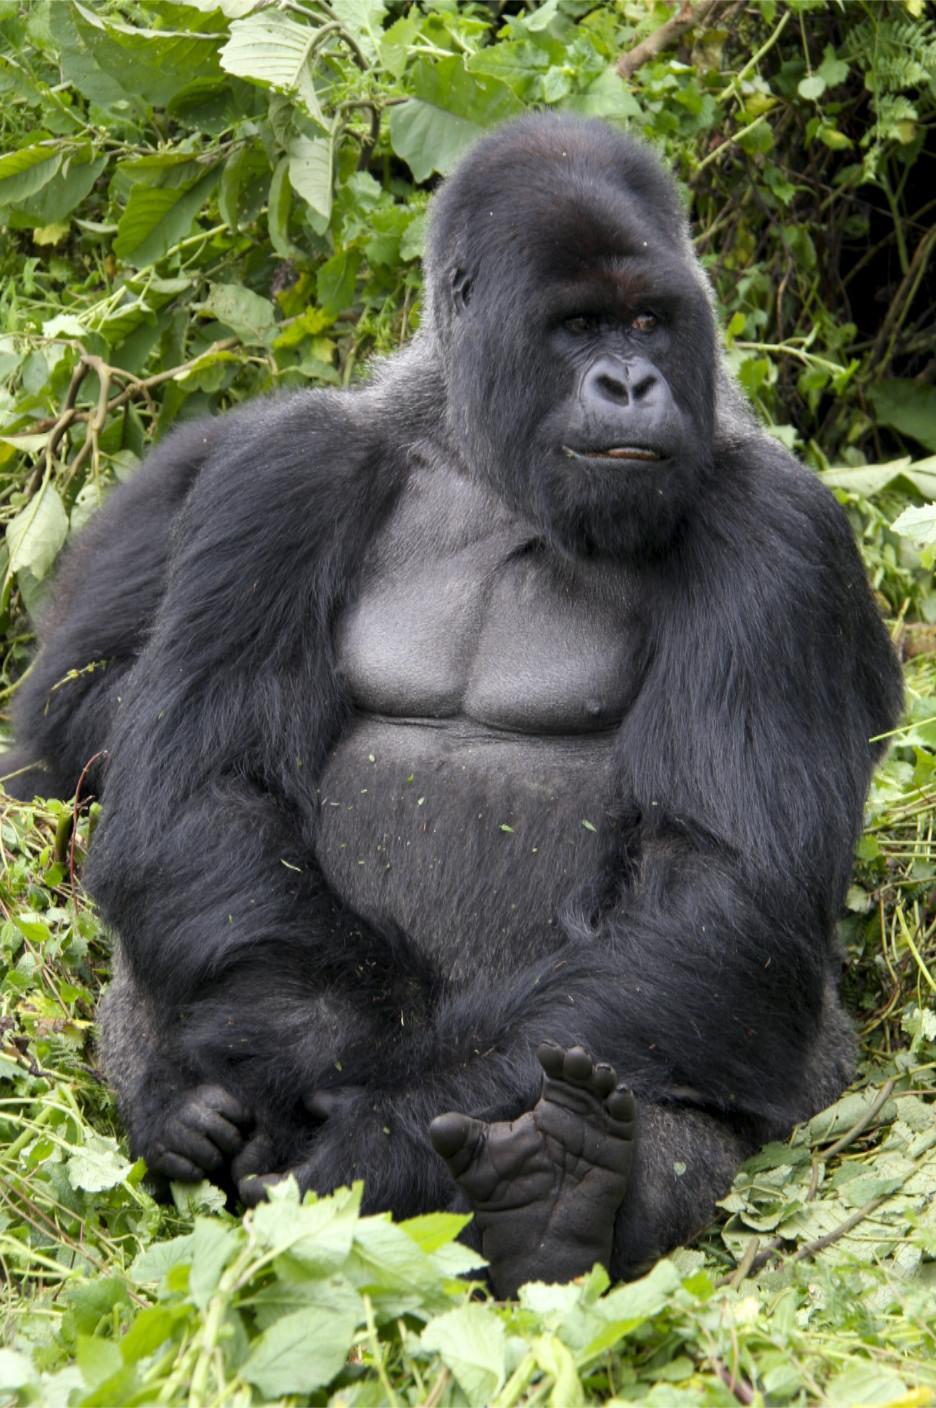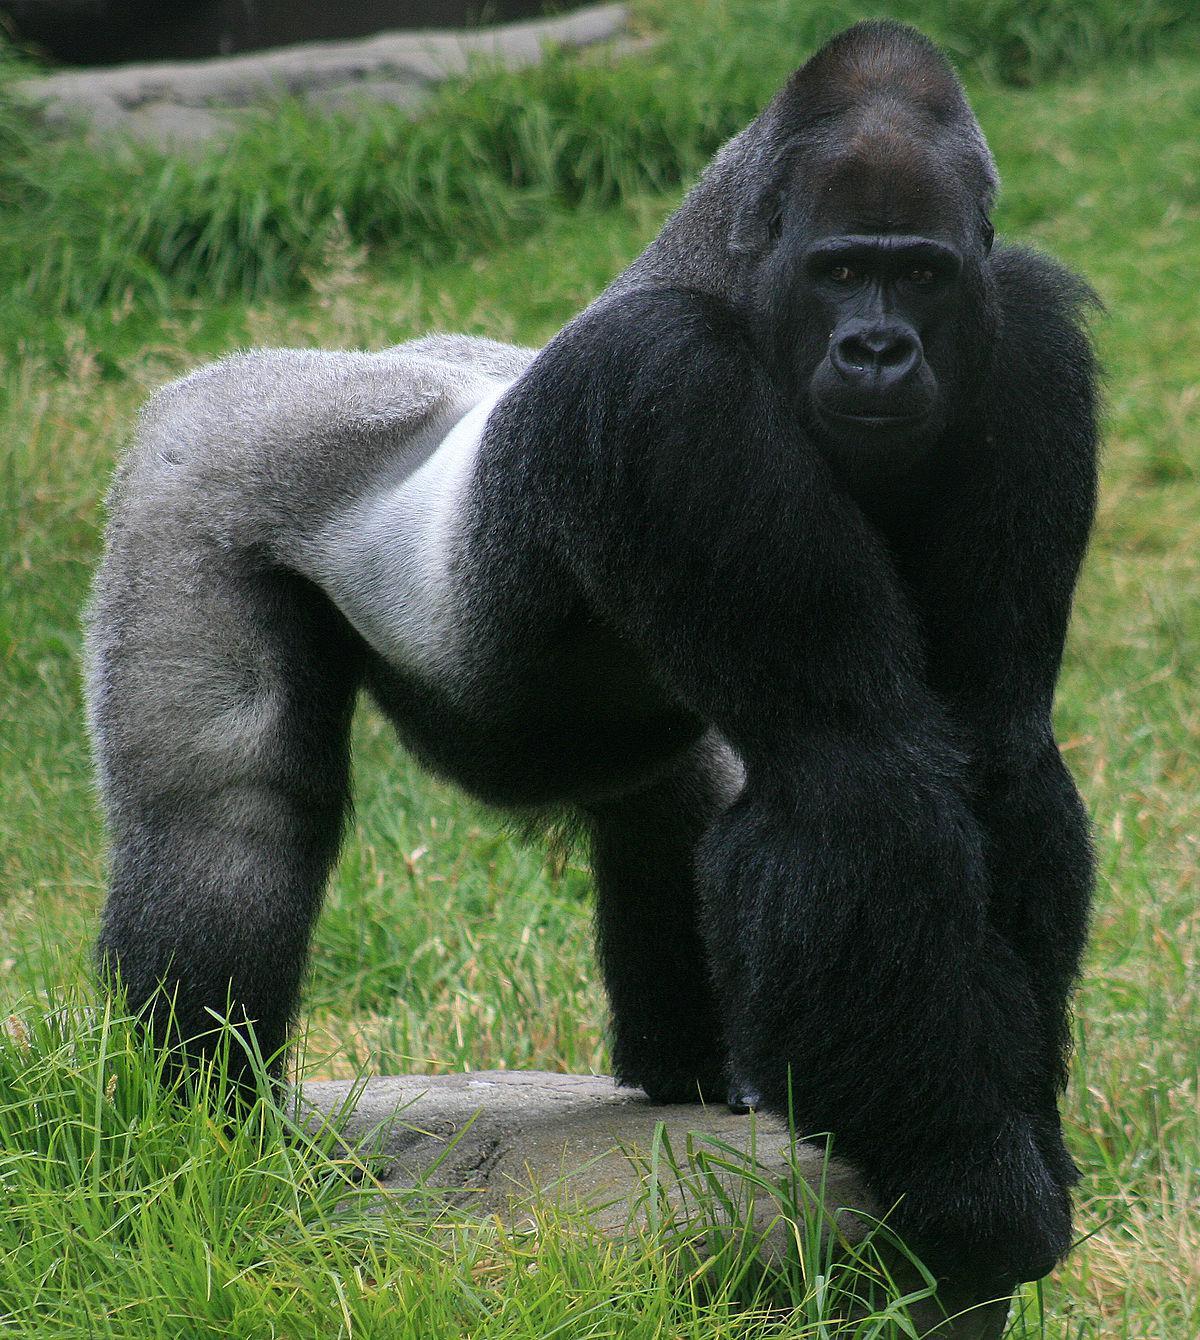The first image is the image on the left, the second image is the image on the right. Evaluate the accuracy of this statement regarding the images: "Baby gorilla is visible in the right image.". Is it true? Answer yes or no. No. The first image is the image on the left, the second image is the image on the right. Given the left and right images, does the statement "There are two adult gorillas and one baby gorilla in one of the images." hold true? Answer yes or no. No. 